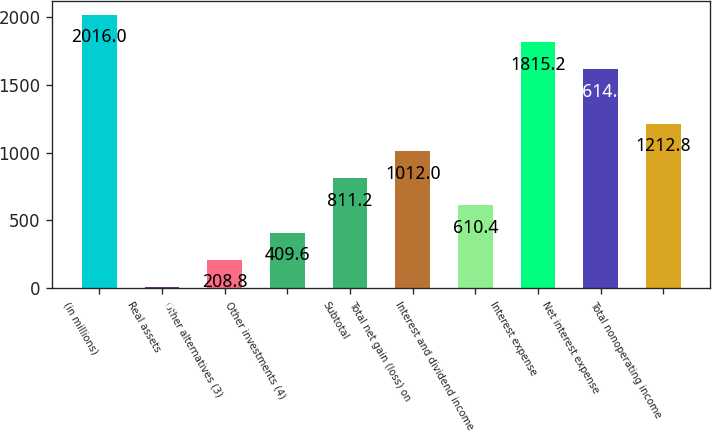<chart> <loc_0><loc_0><loc_500><loc_500><bar_chart><fcel>(in millions)<fcel>Real assets<fcel>Other alternatives (3)<fcel>Other investments (4)<fcel>Subtotal<fcel>Total net gain (loss) on<fcel>Interest and dividend income<fcel>Interest expense<fcel>Net interest expense<fcel>Total nonoperating income<nl><fcel>2016<fcel>8<fcel>208.8<fcel>409.6<fcel>811.2<fcel>1012<fcel>610.4<fcel>1815.2<fcel>1614.4<fcel>1212.8<nl></chart> 